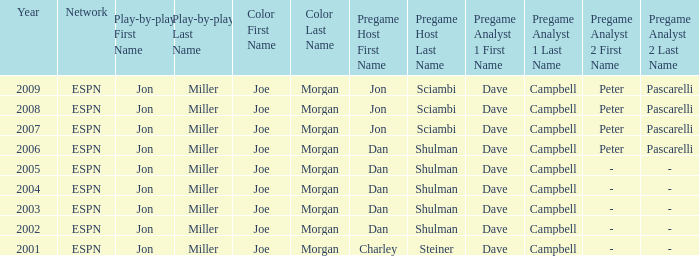Who is the pregame host when the pregame analysts is  Dave Campbell and the year is 2001? Charley Steiner. 